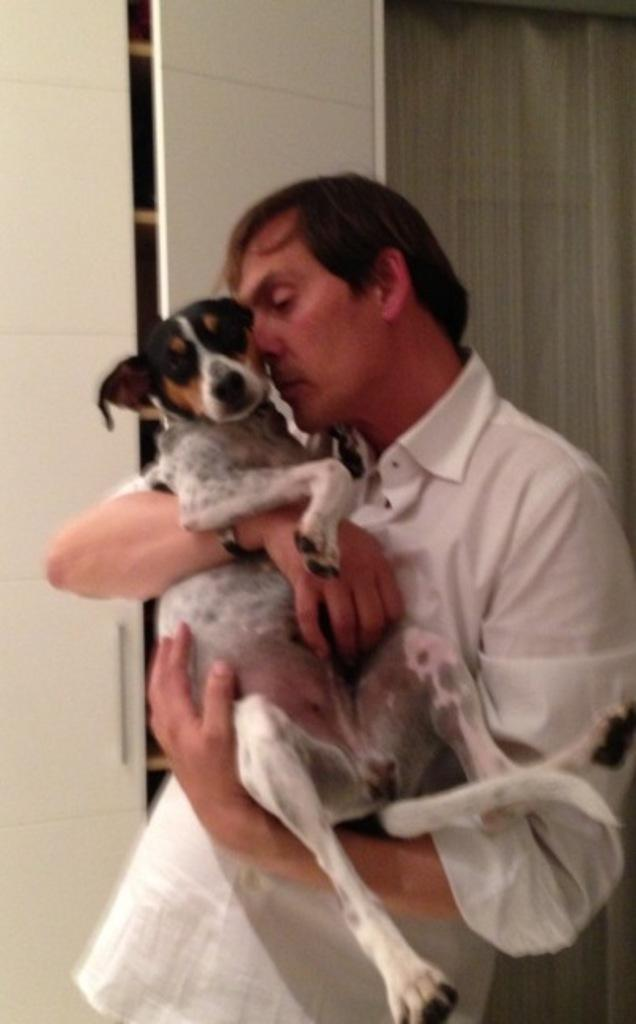Who is present in the image? There is a man in the image. What is the man holding in the image? The man is holding a dog in the image. What can be seen in the background of the image? There is a cupboard in the background of the image. What type of treatment is the man receiving at the event in the image? There is no event or treatment present in the image; it features a man holding a dog with a cupboard in the background. 